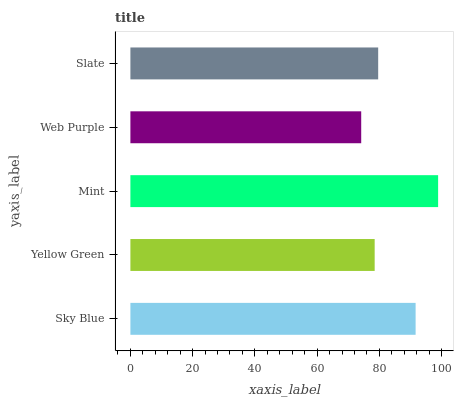Is Web Purple the minimum?
Answer yes or no. Yes. Is Mint the maximum?
Answer yes or no. Yes. Is Yellow Green the minimum?
Answer yes or no. No. Is Yellow Green the maximum?
Answer yes or no. No. Is Sky Blue greater than Yellow Green?
Answer yes or no. Yes. Is Yellow Green less than Sky Blue?
Answer yes or no. Yes. Is Yellow Green greater than Sky Blue?
Answer yes or no. No. Is Sky Blue less than Yellow Green?
Answer yes or no. No. Is Slate the high median?
Answer yes or no. Yes. Is Slate the low median?
Answer yes or no. Yes. Is Sky Blue the high median?
Answer yes or no. No. Is Yellow Green the low median?
Answer yes or no. No. 